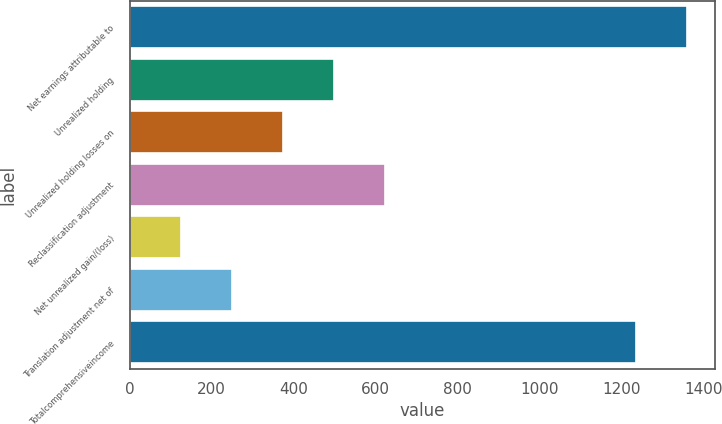Convert chart to OTSL. <chart><loc_0><loc_0><loc_500><loc_500><bar_chart><fcel>Net earnings attributable to<fcel>Unrealized holding<fcel>Unrealized holding losses on<fcel>Reclassification adjustment<fcel>Net unrealized gain/(loss)<fcel>Translation adjustment net of<fcel>Totalcomprehensiveincome<nl><fcel>1359.33<fcel>498.52<fcel>373.99<fcel>623.05<fcel>124.93<fcel>249.46<fcel>1234.8<nl></chart> 